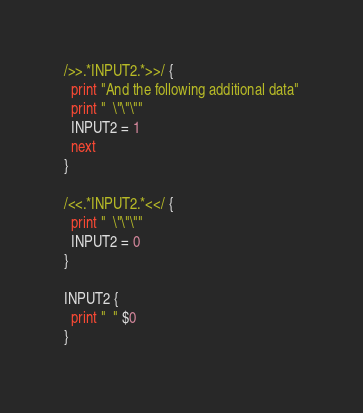Convert code to text. <code><loc_0><loc_0><loc_500><loc_500><_Awk_>/>>.*INPUT2.*>>/ {
  print "And the following additional data"
  print "  \"\"\""
  INPUT2 = 1
  next
}

/<<.*INPUT2.*<</ {
  print "  \"\"\""
  INPUT2 = 0
}

INPUT2 {
  print "  " $0
}
</code> 